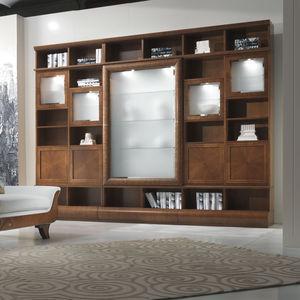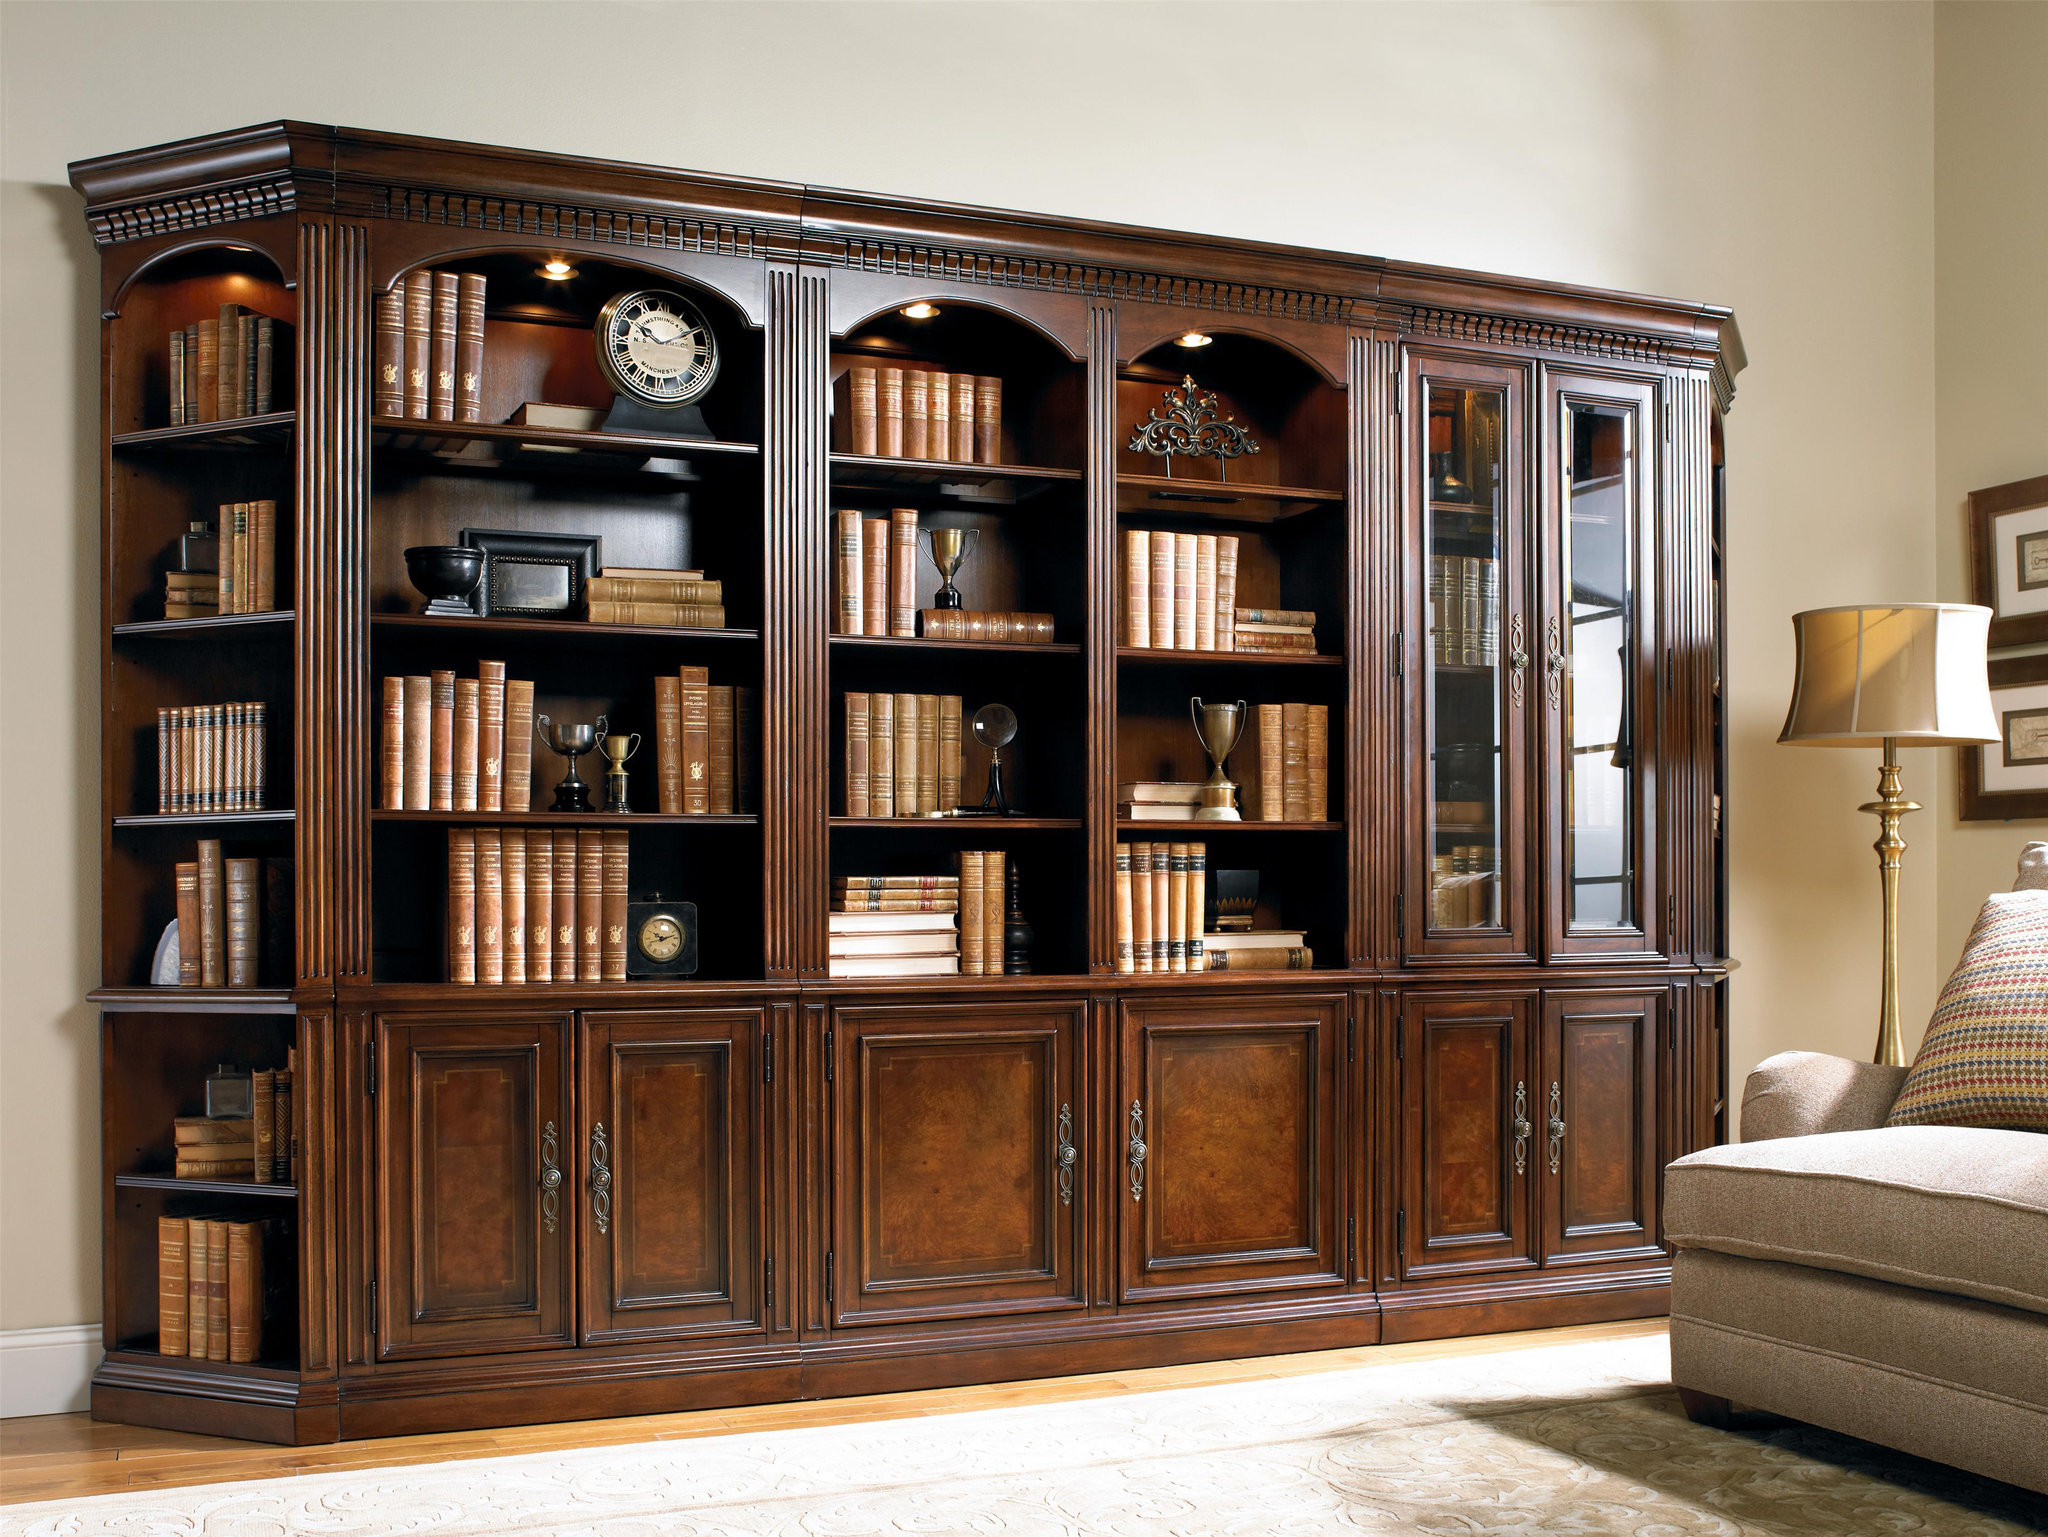The first image is the image on the left, the second image is the image on the right. Examine the images to the left and right. Is the description "There is an empty case of bookshelf." accurate? Answer yes or no. No. 